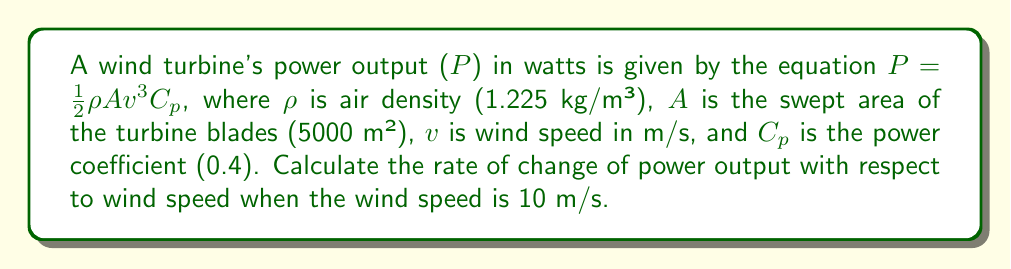Show me your answer to this math problem. To solve this problem, we need to find the derivative of the power output function with respect to wind speed. This will give us the rate of change of power output as wind speed varies.

1. Start with the given equation:
   $P = \frac{1}{2}\rho A v^3 C_p$

2. Substitute the known values:
   $P = \frac{1}{2} \cdot 1.225 \cdot 5000 \cdot v^3 \cdot 0.4$

3. Simplify:
   $P = 1225 v^3$

4. To find the rate of change, we need to differentiate P with respect to v:
   $$\frac{dP}{dv} = 1225 \cdot 3v^2 = 3675v^2$$

5. Now, we need to evaluate this at v = 10 m/s:
   $$\frac{dP}{dv}\bigg|_{v=10} = 3675 \cdot 10^2 = 367,500 \text{ W/(m/s)}$$

This means that when the wind speed is 10 m/s, for every 1 m/s increase in wind speed, the power output increases by 367,500 watts.
Answer: The rate of change of power output with respect to wind speed at 10 m/s is 367,500 W/(m/s). 